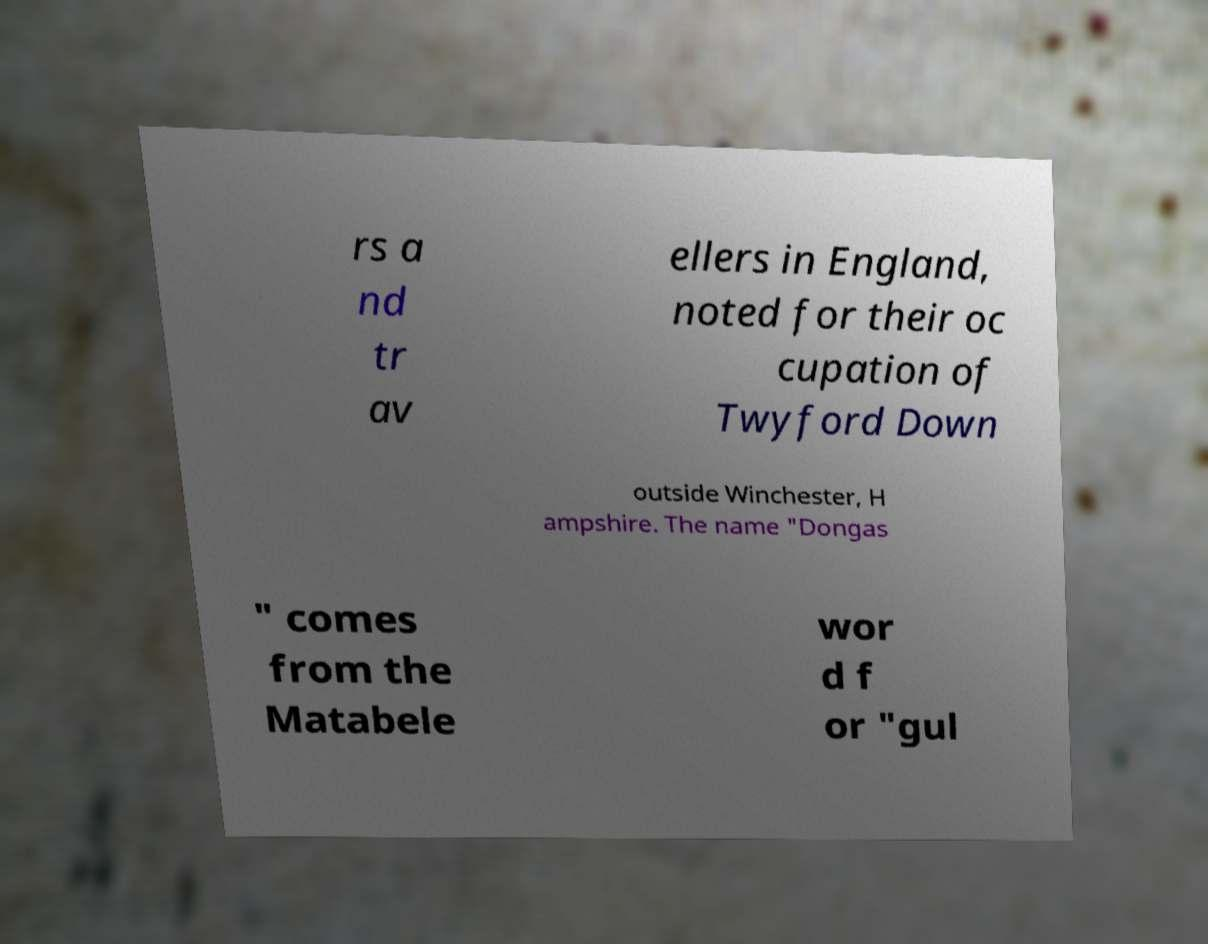Could you assist in decoding the text presented in this image and type it out clearly? rs a nd tr av ellers in England, noted for their oc cupation of Twyford Down outside Winchester, H ampshire. The name "Dongas " comes from the Matabele wor d f or "gul 